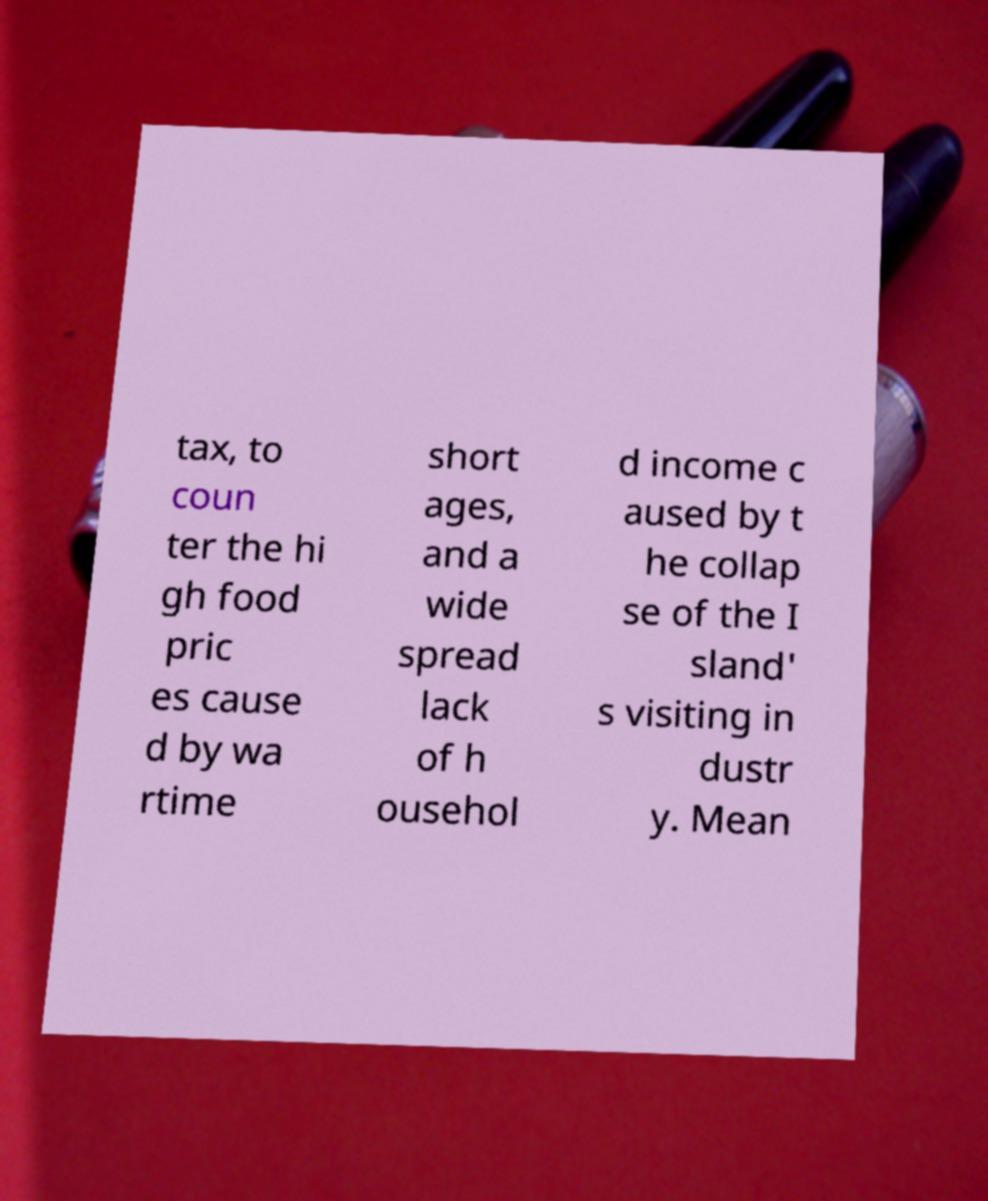Could you assist in decoding the text presented in this image and type it out clearly? tax, to coun ter the hi gh food pric es cause d by wa rtime short ages, and a wide spread lack of h ousehol d income c aused by t he collap se of the I sland' s visiting in dustr y. Mean 